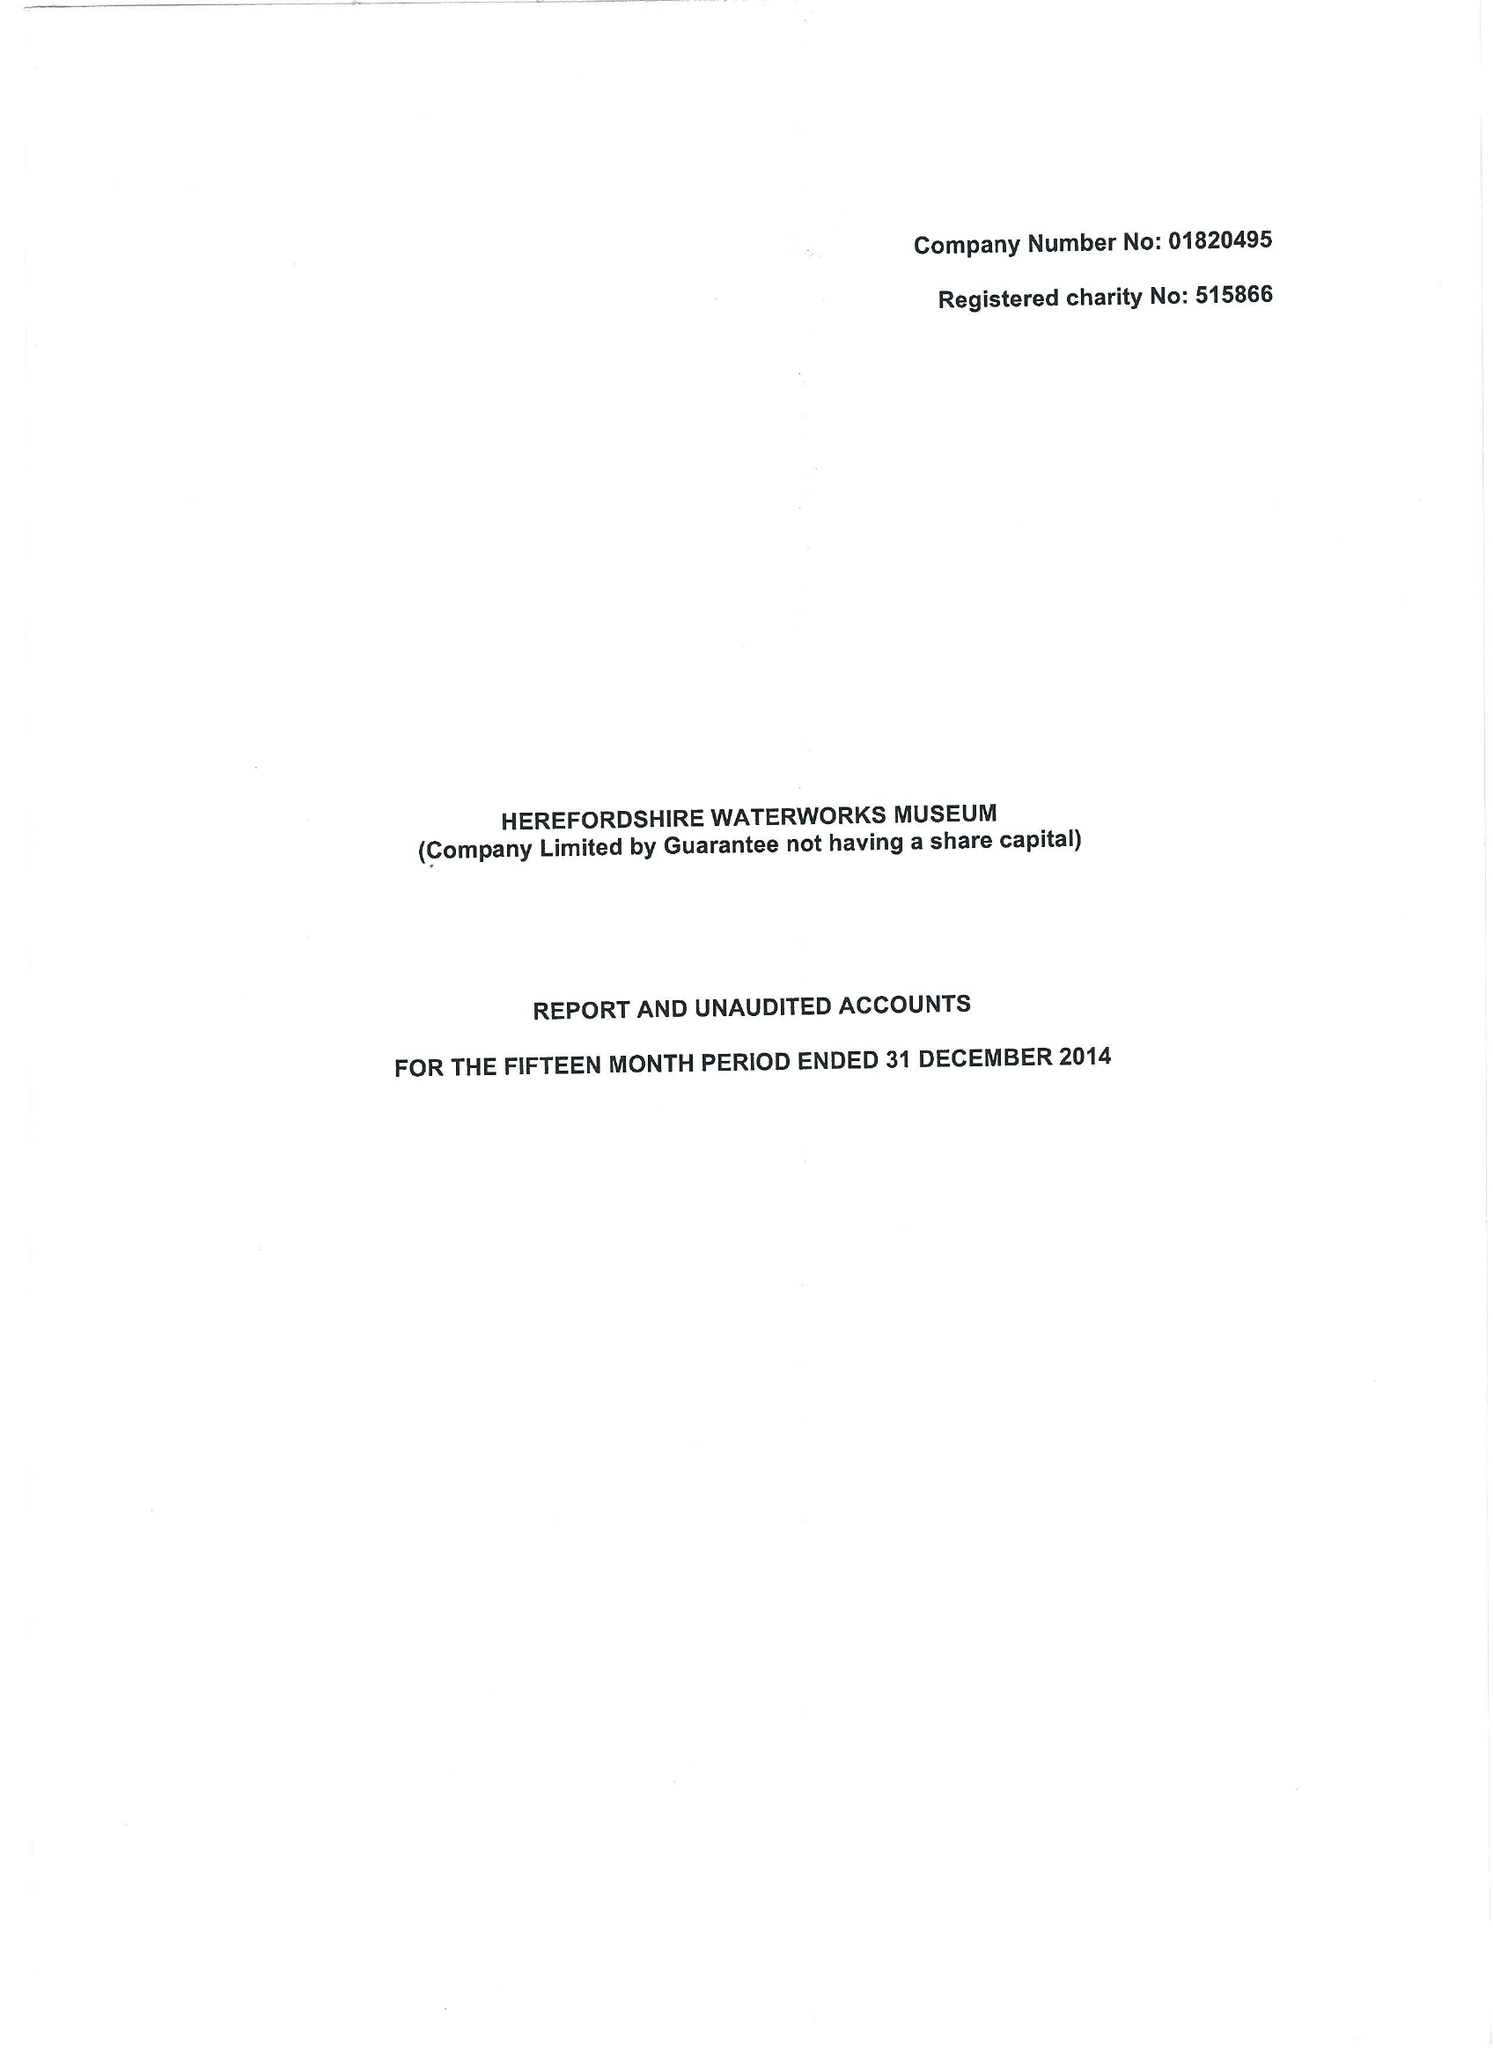What is the value for the spending_annually_in_british_pounds?
Answer the question using a single word or phrase. 72973.00 